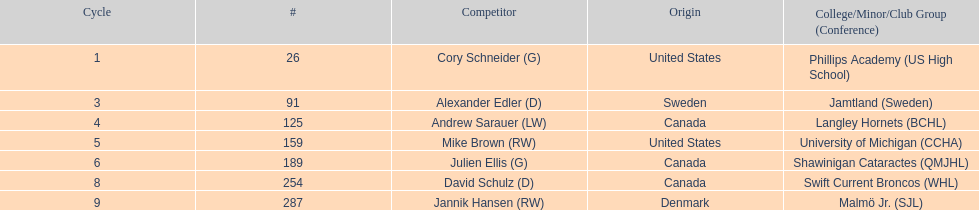What is the name of the last player on this chart? Jannik Hansen (RW). 